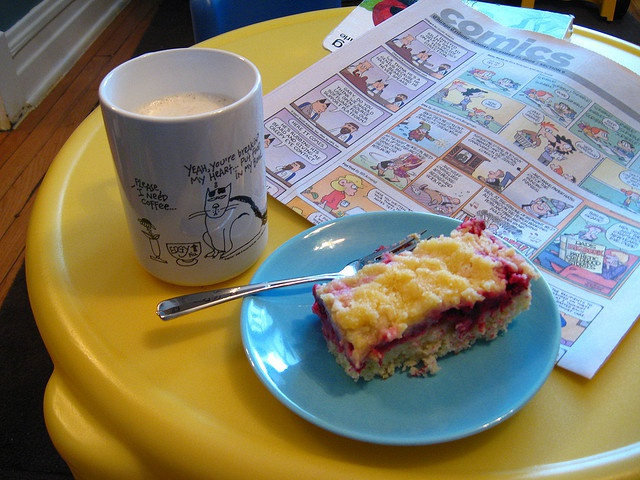Describe the objects in this image and their specific colors. I can see cup in black, gray, darkgray, and olive tones, cake in black, maroon, tan, and olive tones, dining table in black, maroon, and olive tones, and fork in black, gray, and white tones in this image. 